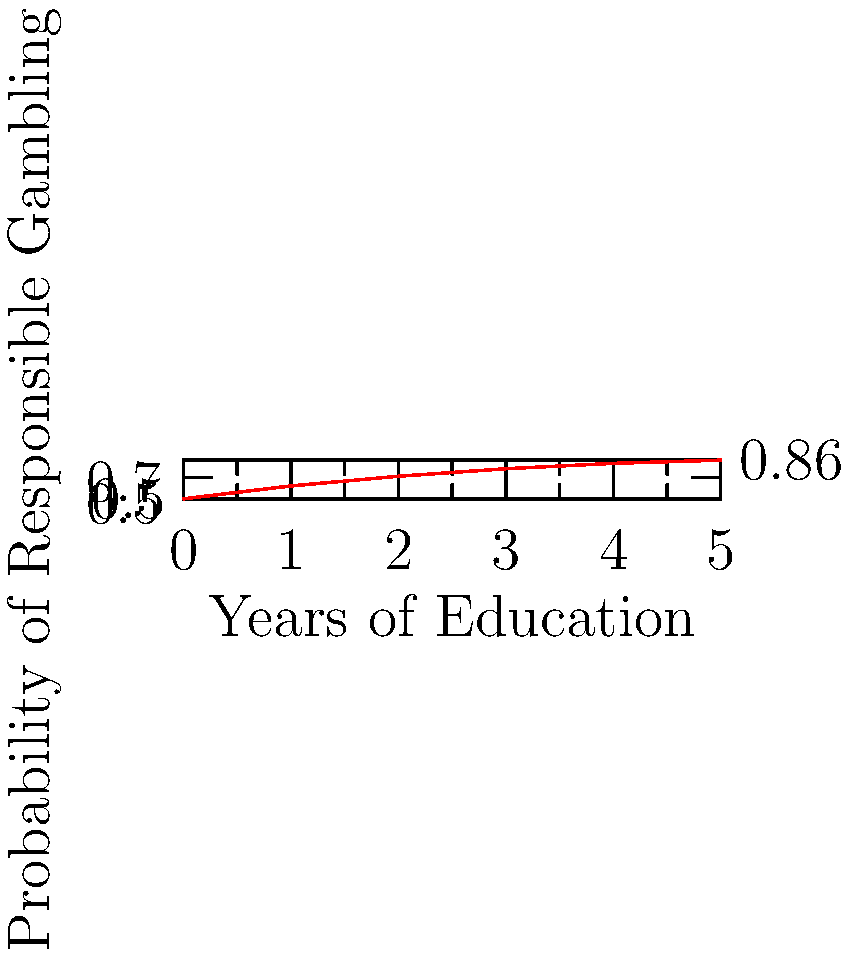The line graph shows the relationship between years of education on responsible gambling and the probability of practicing responsible gambling. If the trend continues linearly, what would be the approximate probability of responsible gambling for someone who has received 7 years of education on the subject? To solve this problem, we need to follow these steps:

1. Identify the linear trend in the given data:
   - At 0 years: probability is 0.5
   - At 5 years: probability is 0.86

2. Calculate the slope of the line:
   $m = \frac{y_2 - y_1}{x_2 - x_1} = \frac{0.86 - 0.5}{5 - 0} = \frac{0.36}{5} = 0.072$ per year

3. Use the point-slope form of a line to create an equation:
   $y - y_1 = m(x - x_1)$
   $y - 0.5 = 0.072(x - 0)$
   $y = 0.072x + 0.5$

4. Plug in x = 7 to find the probability at 7 years:
   $y = 0.072(7) + 0.5 = 0.504 + 0.5 = 1.004$

5. Since probability cannot exceed 1, we cap the result at 1.

Therefore, the approximate probability of responsible gambling for someone with 7 years of education would be 1, or 100%.
Answer: 1 (or 100%) 